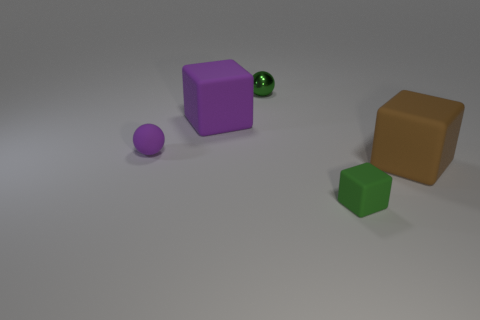Can you describe the lighting and shadows present in the image? The lighting in the image appears to be soft and diffused, creating gentle shadows that originate from the opposite side of each object. The shadows are subtle and stretched out, suggesting a light source that is not overly intense, positioned above and to the left of the objects, casting shadows towards the lower right side of the frame. This soft lighting adds a calm ambiance to the scene. 